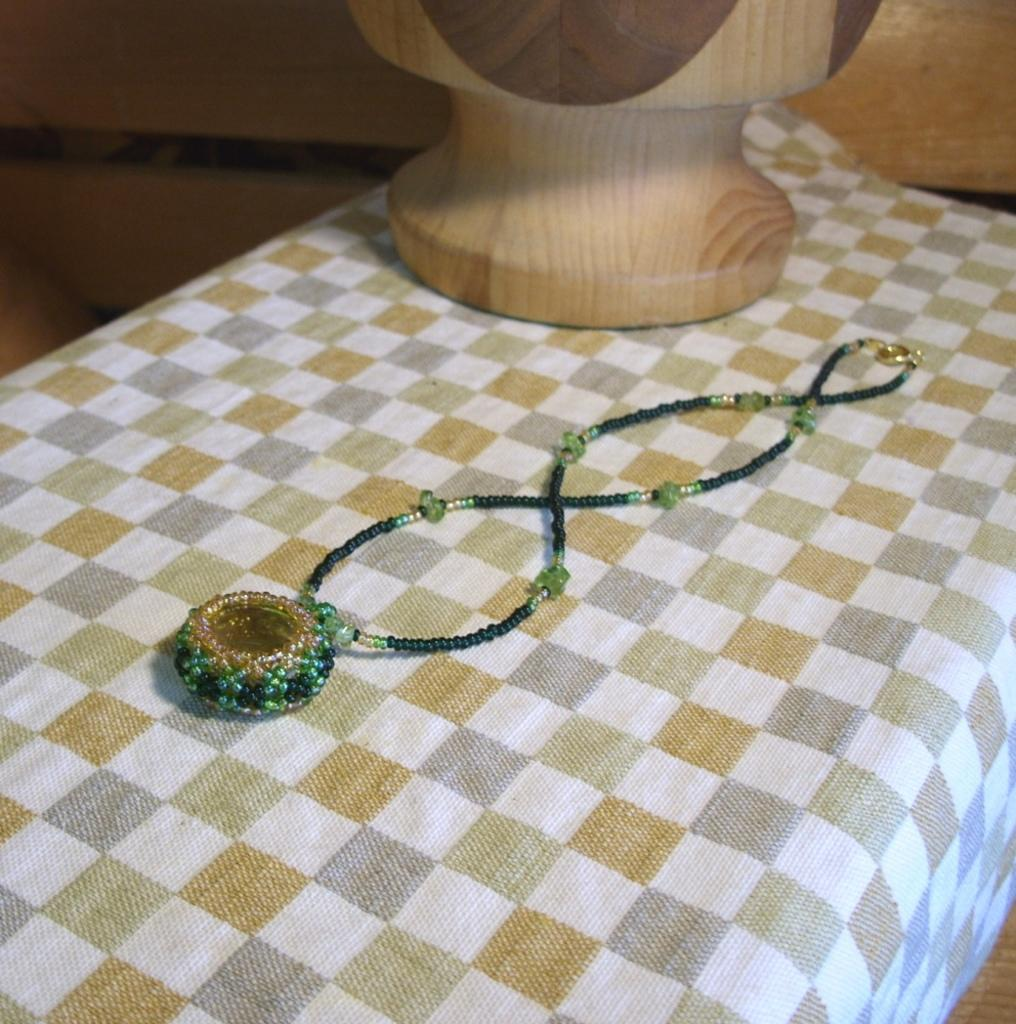What type of material is used to create the structure in the image? The wooden structure in the image is made of wood. What is the small object with a chain in the image? There is a locket with a chain in the image. Where are the wooden structure and the locket with a chain located? Both the wooden structure and the locket with a chain are placed on a table. What type of ink is used to write on the wooden structure in the image? There is no ink or writing present on the wooden structure in the image. How many people are in the group that is holding the locket in the image? There is no group or people holding the locket in the image; it is placed on a table. 